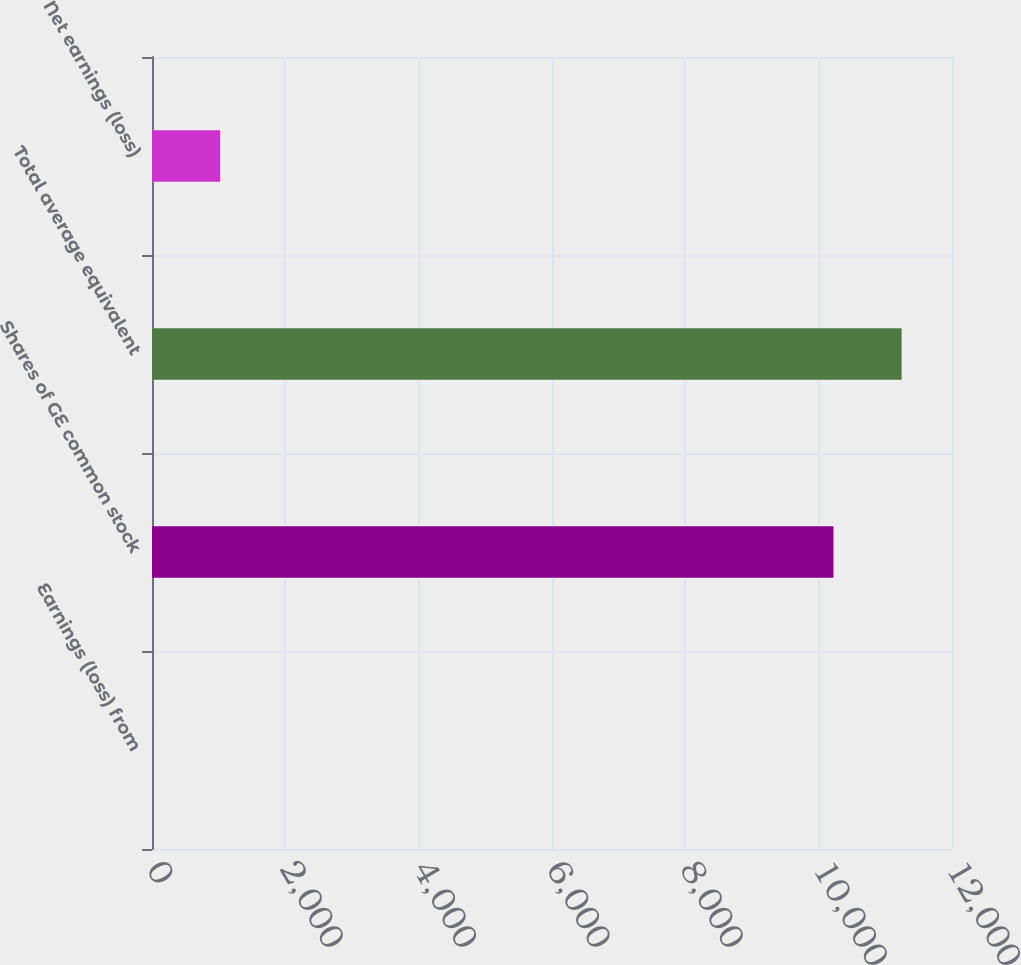Convert chart to OTSL. <chart><loc_0><loc_0><loc_500><loc_500><bar_chart><fcel>Earnings (loss) from<fcel>Shares of GE common stock<fcel>Total average equivalent<fcel>Net earnings (loss)<nl><fcel>0.53<fcel>10222<fcel>11244.1<fcel>1022.68<nl></chart> 